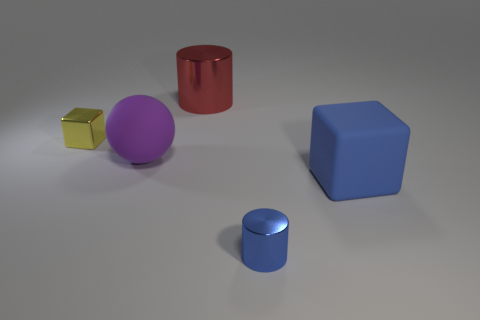Add 1 small shiny cylinders. How many objects exist? 6 Subtract all purple cylinders. Subtract all gray blocks. How many cylinders are left? 2 Subtract all cylinders. How many objects are left? 3 Add 1 tiny metallic objects. How many tiny metallic objects exist? 3 Subtract 0 yellow spheres. How many objects are left? 5 Subtract all tiny blue cubes. Subtract all tiny metal things. How many objects are left? 3 Add 3 tiny yellow metal cubes. How many tiny yellow metal cubes are left? 4 